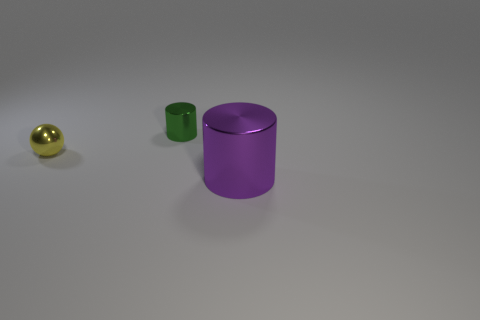Is there any other thing that has the same size as the purple shiny object?
Provide a short and direct response. No. What color is the small cylinder that is the same material as the sphere?
Your answer should be very brief. Green. Are there more large shiny objects that are right of the large metallic cylinder than small green metal things?
Your answer should be compact. No. Are there any blocks?
Your answer should be compact. No. What color is the metallic object in front of the tiny yellow sphere?
Offer a terse response. Purple. What material is the green thing that is the same size as the yellow shiny sphere?
Give a very brief answer. Metal. What number of other things are the same material as the green cylinder?
Give a very brief answer. 2. There is a metal thing that is on the left side of the purple cylinder and to the right of the yellow shiny ball; what is its color?
Ensure brevity in your answer.  Green. How many objects are either metal cylinders behind the big metallic cylinder or purple shiny cubes?
Offer a very short reply. 1. Are there an equal number of big purple shiny cylinders that are right of the tiny metallic cylinder and green cylinders?
Give a very brief answer. Yes. 